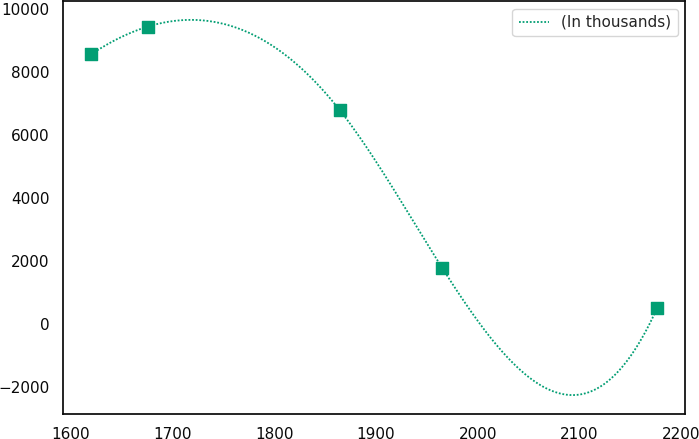<chart> <loc_0><loc_0><loc_500><loc_500><line_chart><ecel><fcel>(In thousands)<nl><fcel>1619.76<fcel>8555.8<nl><fcel>1675.39<fcel>9433.86<nl><fcel>1864.52<fcel>6776.52<nl><fcel>1965.21<fcel>1775.08<nl><fcel>2176.1<fcel>501.75<nl></chart> 